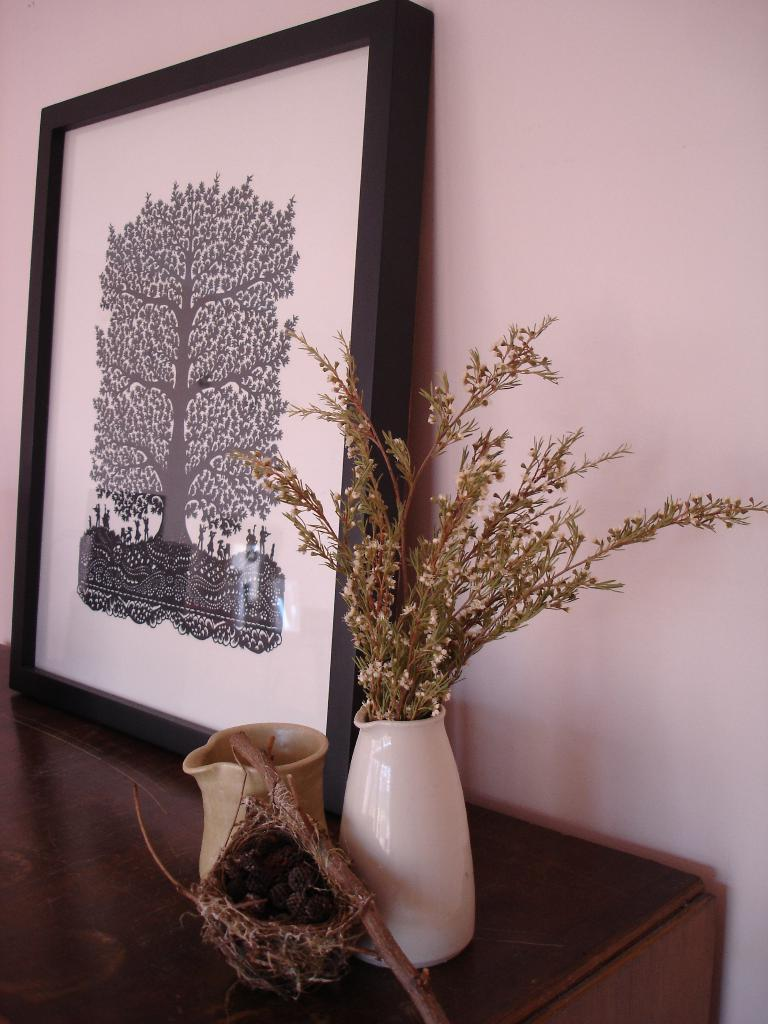What type of object can be seen in the image that typically holds photos? There is a photo frame in the image. What other object can be seen in the image that is often used for holding flowers? There is a flower vase in the image. What is the third object visible in the image that is typically used for storing items? There is a jar in the image. Can you describe the natural object in the image? There appears to be a nest in the image. Where are all these objects located in the image? All these objects are on a table. What can be seen in the background of the image? There is a wall visible in the background of the image. What type of insurance policy is being discussed in the image? There is no mention of insurance or any discussion in the image; it features a photo frame, flower vase, jar, nest, and a wall in the background. What type of drink is being served in the image? There is no drink visible in the image; it only features a photo frame, flower vase, jar, nest, and a wall in the background. 